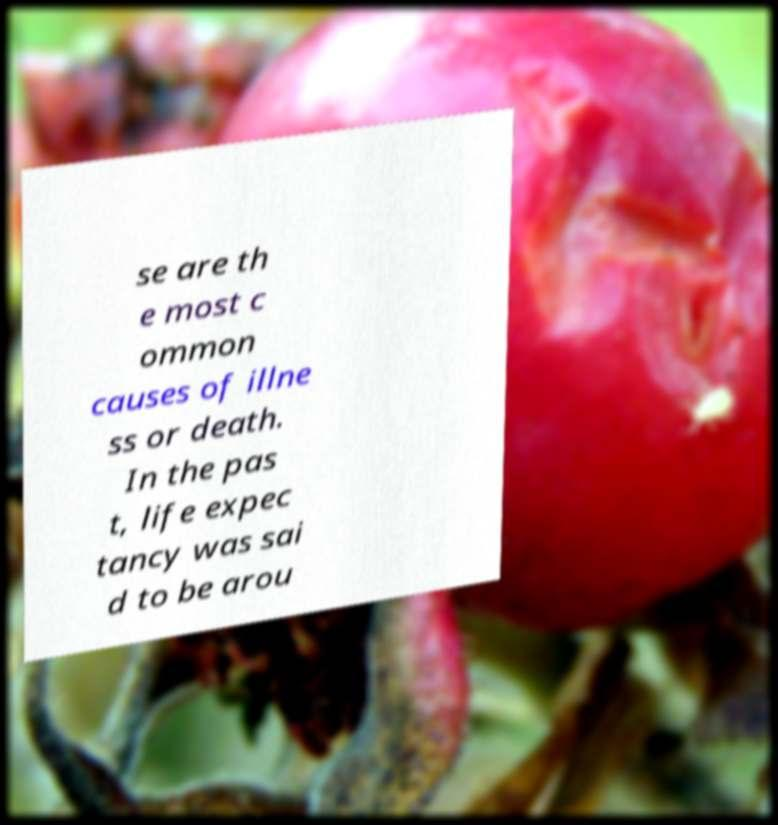For documentation purposes, I need the text within this image transcribed. Could you provide that? se are th e most c ommon causes of illne ss or death. In the pas t, life expec tancy was sai d to be arou 